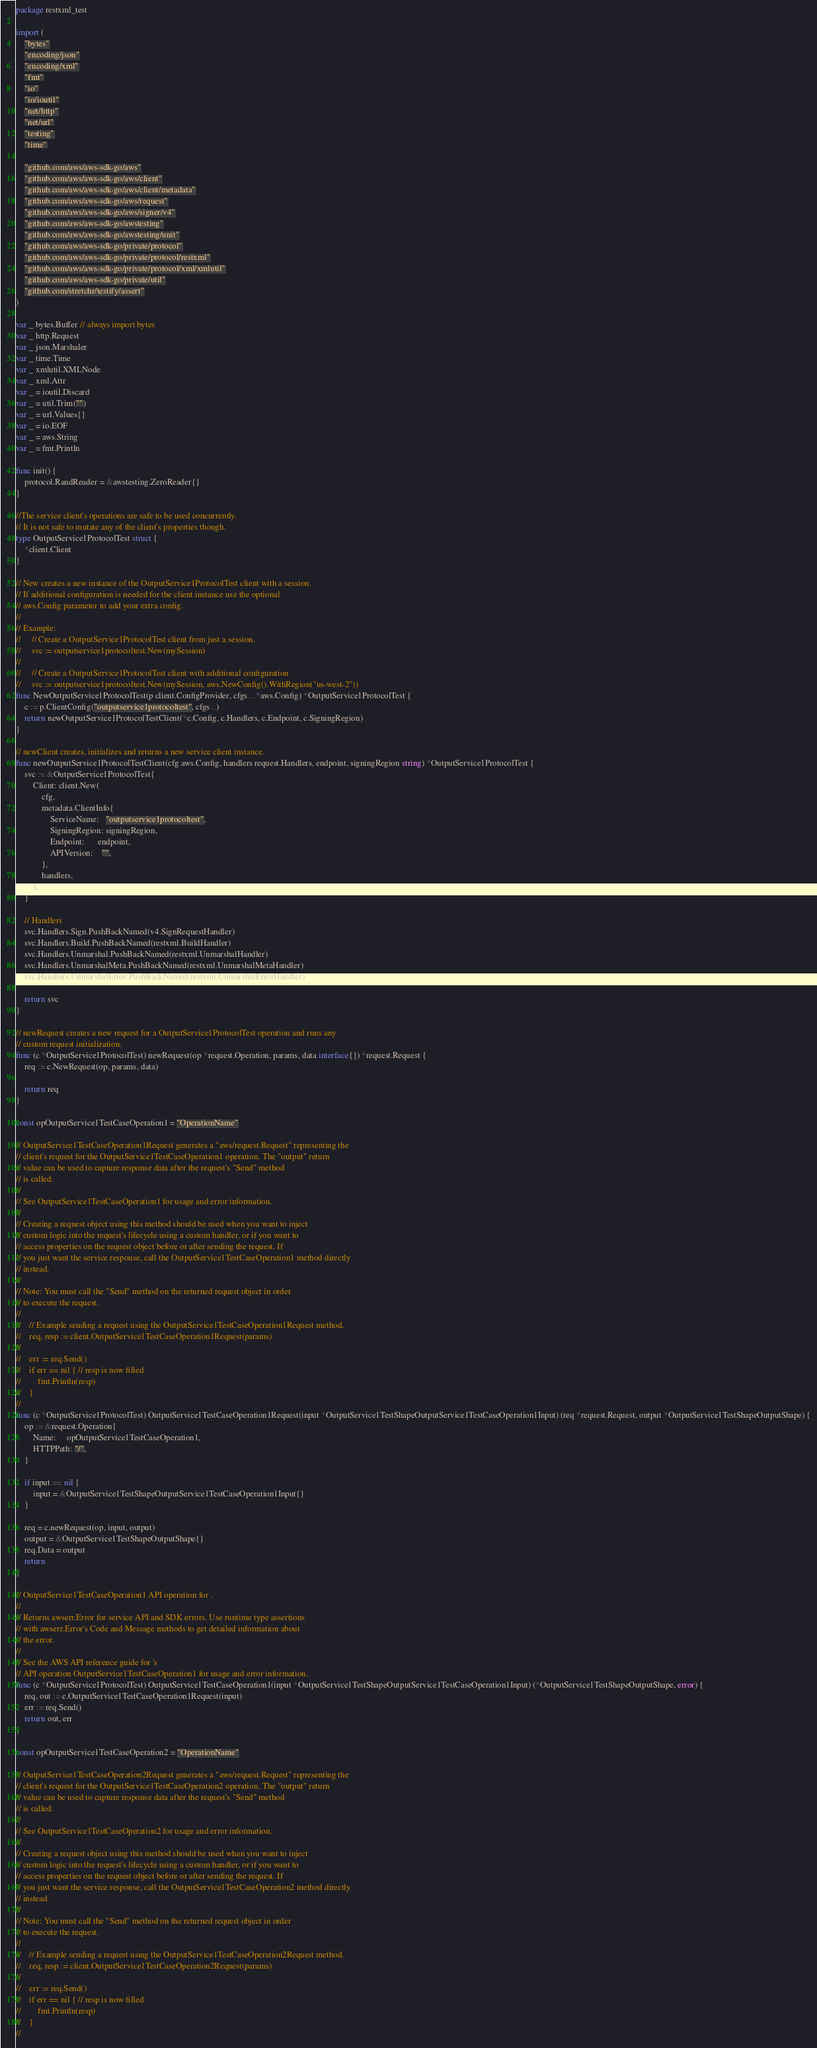Convert code to text. <code><loc_0><loc_0><loc_500><loc_500><_Go_>package restxml_test

import (
	"bytes"
	"encoding/json"
	"encoding/xml"
	"fmt"
	"io"
	"io/ioutil"
	"net/http"
	"net/url"
	"testing"
	"time"

	"github.com/aws/aws-sdk-go/aws"
	"github.com/aws/aws-sdk-go/aws/client"
	"github.com/aws/aws-sdk-go/aws/client/metadata"
	"github.com/aws/aws-sdk-go/aws/request"
	"github.com/aws/aws-sdk-go/aws/signer/v4"
	"github.com/aws/aws-sdk-go/awstesting"
	"github.com/aws/aws-sdk-go/awstesting/unit"
	"github.com/aws/aws-sdk-go/private/protocol"
	"github.com/aws/aws-sdk-go/private/protocol/restxml"
	"github.com/aws/aws-sdk-go/private/protocol/xml/xmlutil"
	"github.com/aws/aws-sdk-go/private/util"
	"github.com/stretchr/testify/assert"
)

var _ bytes.Buffer // always import bytes
var _ http.Request
var _ json.Marshaler
var _ time.Time
var _ xmlutil.XMLNode
var _ xml.Attr
var _ = ioutil.Discard
var _ = util.Trim("")
var _ = url.Values{}
var _ = io.EOF
var _ = aws.String
var _ = fmt.Println

func init() {
	protocol.RandReader = &awstesting.ZeroReader{}
}

//The service client's operations are safe to be used concurrently.
// It is not safe to mutate any of the client's properties though.
type OutputService1ProtocolTest struct {
	*client.Client
}

// New creates a new instance of the OutputService1ProtocolTest client with a session.
// If additional configuration is needed for the client instance use the optional
// aws.Config parameter to add your extra config.
//
// Example:
//     // Create a OutputService1ProtocolTest client from just a session.
//     svc := outputservice1protocoltest.New(mySession)
//
//     // Create a OutputService1ProtocolTest client with additional configuration
//     svc := outputservice1protocoltest.New(mySession, aws.NewConfig().WithRegion("us-west-2"))
func NewOutputService1ProtocolTest(p client.ConfigProvider, cfgs ...*aws.Config) *OutputService1ProtocolTest {
	c := p.ClientConfig("outputservice1protocoltest", cfgs...)
	return newOutputService1ProtocolTestClient(*c.Config, c.Handlers, c.Endpoint, c.SigningRegion)
}

// newClient creates, initializes and returns a new service client instance.
func newOutputService1ProtocolTestClient(cfg aws.Config, handlers request.Handlers, endpoint, signingRegion string) *OutputService1ProtocolTest {
	svc := &OutputService1ProtocolTest{
		Client: client.New(
			cfg,
			metadata.ClientInfo{
				ServiceName:   "outputservice1protocoltest",
				SigningRegion: signingRegion,
				Endpoint:      endpoint,
				APIVersion:    "",
			},
			handlers,
		),
	}

	// Handlers
	svc.Handlers.Sign.PushBackNamed(v4.SignRequestHandler)
	svc.Handlers.Build.PushBackNamed(restxml.BuildHandler)
	svc.Handlers.Unmarshal.PushBackNamed(restxml.UnmarshalHandler)
	svc.Handlers.UnmarshalMeta.PushBackNamed(restxml.UnmarshalMetaHandler)
	svc.Handlers.UnmarshalError.PushBackNamed(restxml.UnmarshalErrorHandler)

	return svc
}

// newRequest creates a new request for a OutputService1ProtocolTest operation and runs any
// custom request initialization.
func (c *OutputService1ProtocolTest) newRequest(op *request.Operation, params, data interface{}) *request.Request {
	req := c.NewRequest(op, params, data)

	return req
}

const opOutputService1TestCaseOperation1 = "OperationName"

// OutputService1TestCaseOperation1Request generates a "aws/request.Request" representing the
// client's request for the OutputService1TestCaseOperation1 operation. The "output" return
// value can be used to capture response data after the request's "Send" method
// is called.
//
// See OutputService1TestCaseOperation1 for usage and error information.
//
// Creating a request object using this method should be used when you want to inject
// custom logic into the request's lifecycle using a custom handler, or if you want to
// access properties on the request object before or after sending the request. If
// you just want the service response, call the OutputService1TestCaseOperation1 method directly
// instead.
//
// Note: You must call the "Send" method on the returned request object in order
// to execute the request.
//
//    // Example sending a request using the OutputService1TestCaseOperation1Request method.
//    req, resp := client.OutputService1TestCaseOperation1Request(params)
//
//    err := req.Send()
//    if err == nil { // resp is now filled
//        fmt.Println(resp)
//    }
//
func (c *OutputService1ProtocolTest) OutputService1TestCaseOperation1Request(input *OutputService1TestShapeOutputService1TestCaseOperation1Input) (req *request.Request, output *OutputService1TestShapeOutputShape) {
	op := &request.Operation{
		Name:     opOutputService1TestCaseOperation1,
		HTTPPath: "/",
	}

	if input == nil {
		input = &OutputService1TestShapeOutputService1TestCaseOperation1Input{}
	}

	req = c.newRequest(op, input, output)
	output = &OutputService1TestShapeOutputShape{}
	req.Data = output
	return
}

// OutputService1TestCaseOperation1 API operation for .
//
// Returns awserr.Error for service API and SDK errors. Use runtime type assertions
// with awserr.Error's Code and Message methods to get detailed information about
// the error.
//
// See the AWS API reference guide for 's
// API operation OutputService1TestCaseOperation1 for usage and error information.
func (c *OutputService1ProtocolTest) OutputService1TestCaseOperation1(input *OutputService1TestShapeOutputService1TestCaseOperation1Input) (*OutputService1TestShapeOutputShape, error) {
	req, out := c.OutputService1TestCaseOperation1Request(input)
	err := req.Send()
	return out, err
}

const opOutputService1TestCaseOperation2 = "OperationName"

// OutputService1TestCaseOperation2Request generates a "aws/request.Request" representing the
// client's request for the OutputService1TestCaseOperation2 operation. The "output" return
// value can be used to capture response data after the request's "Send" method
// is called.
//
// See OutputService1TestCaseOperation2 for usage and error information.
//
// Creating a request object using this method should be used when you want to inject
// custom logic into the request's lifecycle using a custom handler, or if you want to
// access properties on the request object before or after sending the request. If
// you just want the service response, call the OutputService1TestCaseOperation2 method directly
// instead.
//
// Note: You must call the "Send" method on the returned request object in order
// to execute the request.
//
//    // Example sending a request using the OutputService1TestCaseOperation2Request method.
//    req, resp := client.OutputService1TestCaseOperation2Request(params)
//
//    err := req.Send()
//    if err == nil { // resp is now filled
//        fmt.Println(resp)
//    }
//</code> 